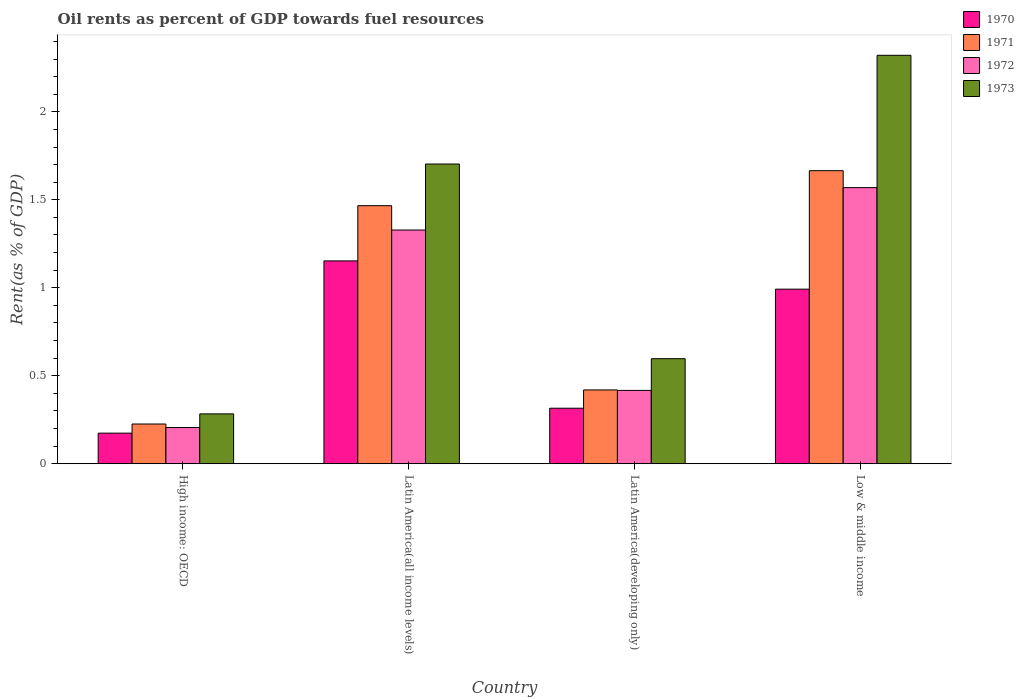Are the number of bars per tick equal to the number of legend labels?
Your answer should be very brief. Yes. Are the number of bars on each tick of the X-axis equal?
Give a very brief answer. Yes. How many bars are there on the 4th tick from the left?
Keep it short and to the point. 4. How many bars are there on the 4th tick from the right?
Make the answer very short. 4. What is the label of the 3rd group of bars from the left?
Offer a terse response. Latin America(developing only). In how many cases, is the number of bars for a given country not equal to the number of legend labels?
Your answer should be compact. 0. What is the oil rent in 1972 in Low & middle income?
Provide a short and direct response. 1.57. Across all countries, what is the maximum oil rent in 1970?
Your answer should be compact. 1.15. Across all countries, what is the minimum oil rent in 1973?
Offer a terse response. 0.28. In which country was the oil rent in 1971 minimum?
Provide a succinct answer. High income: OECD. What is the total oil rent in 1972 in the graph?
Keep it short and to the point. 3.52. What is the difference between the oil rent in 1972 in High income: OECD and that in Latin America(all income levels)?
Your answer should be very brief. -1.12. What is the difference between the oil rent in 1971 in Low & middle income and the oil rent in 1972 in Latin America(all income levels)?
Your response must be concise. 0.34. What is the average oil rent in 1973 per country?
Give a very brief answer. 1.23. What is the difference between the oil rent of/in 1971 and oil rent of/in 1970 in Low & middle income?
Your response must be concise. 0.67. What is the ratio of the oil rent in 1972 in Latin America(developing only) to that in Low & middle income?
Keep it short and to the point. 0.27. Is the difference between the oil rent in 1971 in Latin America(all income levels) and Latin America(developing only) greater than the difference between the oil rent in 1970 in Latin America(all income levels) and Latin America(developing only)?
Your answer should be very brief. Yes. What is the difference between the highest and the second highest oil rent in 1970?
Ensure brevity in your answer.  -0.16. What is the difference between the highest and the lowest oil rent in 1970?
Your answer should be very brief. 0.98. In how many countries, is the oil rent in 1971 greater than the average oil rent in 1971 taken over all countries?
Your answer should be very brief. 2. Is it the case that in every country, the sum of the oil rent in 1970 and oil rent in 1971 is greater than the sum of oil rent in 1973 and oil rent in 1972?
Keep it short and to the point. No. What does the 4th bar from the right in Latin America(all income levels) represents?
Make the answer very short. 1970. What is the difference between two consecutive major ticks on the Y-axis?
Offer a terse response. 0.5. Are the values on the major ticks of Y-axis written in scientific E-notation?
Ensure brevity in your answer.  No. Does the graph contain any zero values?
Provide a short and direct response. No. Does the graph contain grids?
Your answer should be compact. No. How are the legend labels stacked?
Make the answer very short. Vertical. What is the title of the graph?
Give a very brief answer. Oil rents as percent of GDP towards fuel resources. What is the label or title of the Y-axis?
Your response must be concise. Rent(as % of GDP). What is the Rent(as % of GDP) of 1970 in High income: OECD?
Ensure brevity in your answer.  0.17. What is the Rent(as % of GDP) in 1971 in High income: OECD?
Your answer should be very brief. 0.23. What is the Rent(as % of GDP) of 1972 in High income: OECD?
Your answer should be compact. 0.21. What is the Rent(as % of GDP) in 1973 in High income: OECD?
Your answer should be very brief. 0.28. What is the Rent(as % of GDP) in 1970 in Latin America(all income levels)?
Provide a short and direct response. 1.15. What is the Rent(as % of GDP) in 1971 in Latin America(all income levels)?
Keep it short and to the point. 1.47. What is the Rent(as % of GDP) of 1972 in Latin America(all income levels)?
Your answer should be very brief. 1.33. What is the Rent(as % of GDP) of 1973 in Latin America(all income levels)?
Offer a terse response. 1.7. What is the Rent(as % of GDP) of 1970 in Latin America(developing only)?
Your answer should be compact. 0.32. What is the Rent(as % of GDP) of 1971 in Latin America(developing only)?
Provide a succinct answer. 0.42. What is the Rent(as % of GDP) of 1972 in Latin America(developing only)?
Your answer should be compact. 0.42. What is the Rent(as % of GDP) in 1973 in Latin America(developing only)?
Keep it short and to the point. 0.6. What is the Rent(as % of GDP) of 1970 in Low & middle income?
Your answer should be compact. 0.99. What is the Rent(as % of GDP) of 1971 in Low & middle income?
Offer a very short reply. 1.67. What is the Rent(as % of GDP) in 1972 in Low & middle income?
Offer a terse response. 1.57. What is the Rent(as % of GDP) of 1973 in Low & middle income?
Keep it short and to the point. 2.32. Across all countries, what is the maximum Rent(as % of GDP) of 1970?
Your answer should be compact. 1.15. Across all countries, what is the maximum Rent(as % of GDP) in 1971?
Your answer should be very brief. 1.67. Across all countries, what is the maximum Rent(as % of GDP) in 1972?
Your answer should be compact. 1.57. Across all countries, what is the maximum Rent(as % of GDP) of 1973?
Ensure brevity in your answer.  2.32. Across all countries, what is the minimum Rent(as % of GDP) of 1970?
Offer a terse response. 0.17. Across all countries, what is the minimum Rent(as % of GDP) of 1971?
Provide a short and direct response. 0.23. Across all countries, what is the minimum Rent(as % of GDP) of 1972?
Offer a very short reply. 0.21. Across all countries, what is the minimum Rent(as % of GDP) in 1973?
Give a very brief answer. 0.28. What is the total Rent(as % of GDP) in 1970 in the graph?
Make the answer very short. 2.63. What is the total Rent(as % of GDP) of 1971 in the graph?
Give a very brief answer. 3.78. What is the total Rent(as % of GDP) of 1972 in the graph?
Make the answer very short. 3.52. What is the total Rent(as % of GDP) in 1973 in the graph?
Give a very brief answer. 4.9. What is the difference between the Rent(as % of GDP) in 1970 in High income: OECD and that in Latin America(all income levels)?
Offer a terse response. -0.98. What is the difference between the Rent(as % of GDP) in 1971 in High income: OECD and that in Latin America(all income levels)?
Your answer should be very brief. -1.24. What is the difference between the Rent(as % of GDP) of 1972 in High income: OECD and that in Latin America(all income levels)?
Provide a succinct answer. -1.12. What is the difference between the Rent(as % of GDP) in 1973 in High income: OECD and that in Latin America(all income levels)?
Give a very brief answer. -1.42. What is the difference between the Rent(as % of GDP) of 1970 in High income: OECD and that in Latin America(developing only)?
Offer a very short reply. -0.14. What is the difference between the Rent(as % of GDP) of 1971 in High income: OECD and that in Latin America(developing only)?
Make the answer very short. -0.19. What is the difference between the Rent(as % of GDP) of 1972 in High income: OECD and that in Latin America(developing only)?
Your response must be concise. -0.21. What is the difference between the Rent(as % of GDP) of 1973 in High income: OECD and that in Latin America(developing only)?
Your answer should be very brief. -0.31. What is the difference between the Rent(as % of GDP) of 1970 in High income: OECD and that in Low & middle income?
Provide a short and direct response. -0.82. What is the difference between the Rent(as % of GDP) of 1971 in High income: OECD and that in Low & middle income?
Offer a very short reply. -1.44. What is the difference between the Rent(as % of GDP) of 1972 in High income: OECD and that in Low & middle income?
Give a very brief answer. -1.36. What is the difference between the Rent(as % of GDP) in 1973 in High income: OECD and that in Low & middle income?
Your response must be concise. -2.04. What is the difference between the Rent(as % of GDP) in 1970 in Latin America(all income levels) and that in Latin America(developing only)?
Your answer should be very brief. 0.84. What is the difference between the Rent(as % of GDP) in 1971 in Latin America(all income levels) and that in Latin America(developing only)?
Your answer should be very brief. 1.05. What is the difference between the Rent(as % of GDP) of 1972 in Latin America(all income levels) and that in Latin America(developing only)?
Your answer should be very brief. 0.91. What is the difference between the Rent(as % of GDP) of 1973 in Latin America(all income levels) and that in Latin America(developing only)?
Your answer should be very brief. 1.11. What is the difference between the Rent(as % of GDP) of 1970 in Latin America(all income levels) and that in Low & middle income?
Make the answer very short. 0.16. What is the difference between the Rent(as % of GDP) of 1971 in Latin America(all income levels) and that in Low & middle income?
Ensure brevity in your answer.  -0.2. What is the difference between the Rent(as % of GDP) in 1972 in Latin America(all income levels) and that in Low & middle income?
Ensure brevity in your answer.  -0.24. What is the difference between the Rent(as % of GDP) in 1973 in Latin America(all income levels) and that in Low & middle income?
Ensure brevity in your answer.  -0.62. What is the difference between the Rent(as % of GDP) of 1970 in Latin America(developing only) and that in Low & middle income?
Keep it short and to the point. -0.68. What is the difference between the Rent(as % of GDP) of 1971 in Latin America(developing only) and that in Low & middle income?
Provide a short and direct response. -1.25. What is the difference between the Rent(as % of GDP) in 1972 in Latin America(developing only) and that in Low & middle income?
Keep it short and to the point. -1.15. What is the difference between the Rent(as % of GDP) of 1973 in Latin America(developing only) and that in Low & middle income?
Offer a very short reply. -1.72. What is the difference between the Rent(as % of GDP) in 1970 in High income: OECD and the Rent(as % of GDP) in 1971 in Latin America(all income levels)?
Make the answer very short. -1.29. What is the difference between the Rent(as % of GDP) in 1970 in High income: OECD and the Rent(as % of GDP) in 1972 in Latin America(all income levels)?
Provide a short and direct response. -1.15. What is the difference between the Rent(as % of GDP) in 1970 in High income: OECD and the Rent(as % of GDP) in 1973 in Latin America(all income levels)?
Offer a terse response. -1.53. What is the difference between the Rent(as % of GDP) of 1971 in High income: OECD and the Rent(as % of GDP) of 1972 in Latin America(all income levels)?
Your answer should be very brief. -1.1. What is the difference between the Rent(as % of GDP) of 1971 in High income: OECD and the Rent(as % of GDP) of 1973 in Latin America(all income levels)?
Your response must be concise. -1.48. What is the difference between the Rent(as % of GDP) in 1972 in High income: OECD and the Rent(as % of GDP) in 1973 in Latin America(all income levels)?
Give a very brief answer. -1.5. What is the difference between the Rent(as % of GDP) of 1970 in High income: OECD and the Rent(as % of GDP) of 1971 in Latin America(developing only)?
Provide a succinct answer. -0.25. What is the difference between the Rent(as % of GDP) of 1970 in High income: OECD and the Rent(as % of GDP) of 1972 in Latin America(developing only)?
Provide a short and direct response. -0.24. What is the difference between the Rent(as % of GDP) in 1970 in High income: OECD and the Rent(as % of GDP) in 1973 in Latin America(developing only)?
Your response must be concise. -0.42. What is the difference between the Rent(as % of GDP) in 1971 in High income: OECD and the Rent(as % of GDP) in 1972 in Latin America(developing only)?
Provide a short and direct response. -0.19. What is the difference between the Rent(as % of GDP) of 1971 in High income: OECD and the Rent(as % of GDP) of 1973 in Latin America(developing only)?
Offer a terse response. -0.37. What is the difference between the Rent(as % of GDP) in 1972 in High income: OECD and the Rent(as % of GDP) in 1973 in Latin America(developing only)?
Your response must be concise. -0.39. What is the difference between the Rent(as % of GDP) in 1970 in High income: OECD and the Rent(as % of GDP) in 1971 in Low & middle income?
Provide a short and direct response. -1.49. What is the difference between the Rent(as % of GDP) in 1970 in High income: OECD and the Rent(as % of GDP) in 1972 in Low & middle income?
Offer a terse response. -1.4. What is the difference between the Rent(as % of GDP) of 1970 in High income: OECD and the Rent(as % of GDP) of 1973 in Low & middle income?
Your answer should be compact. -2.15. What is the difference between the Rent(as % of GDP) of 1971 in High income: OECD and the Rent(as % of GDP) of 1972 in Low & middle income?
Offer a terse response. -1.34. What is the difference between the Rent(as % of GDP) of 1971 in High income: OECD and the Rent(as % of GDP) of 1973 in Low & middle income?
Ensure brevity in your answer.  -2.1. What is the difference between the Rent(as % of GDP) in 1972 in High income: OECD and the Rent(as % of GDP) in 1973 in Low & middle income?
Keep it short and to the point. -2.12. What is the difference between the Rent(as % of GDP) in 1970 in Latin America(all income levels) and the Rent(as % of GDP) in 1971 in Latin America(developing only)?
Your answer should be very brief. 0.73. What is the difference between the Rent(as % of GDP) in 1970 in Latin America(all income levels) and the Rent(as % of GDP) in 1972 in Latin America(developing only)?
Provide a short and direct response. 0.74. What is the difference between the Rent(as % of GDP) in 1970 in Latin America(all income levels) and the Rent(as % of GDP) in 1973 in Latin America(developing only)?
Provide a short and direct response. 0.56. What is the difference between the Rent(as % of GDP) of 1971 in Latin America(all income levels) and the Rent(as % of GDP) of 1972 in Latin America(developing only)?
Give a very brief answer. 1.05. What is the difference between the Rent(as % of GDP) of 1971 in Latin America(all income levels) and the Rent(as % of GDP) of 1973 in Latin America(developing only)?
Ensure brevity in your answer.  0.87. What is the difference between the Rent(as % of GDP) of 1972 in Latin America(all income levels) and the Rent(as % of GDP) of 1973 in Latin America(developing only)?
Provide a short and direct response. 0.73. What is the difference between the Rent(as % of GDP) of 1970 in Latin America(all income levels) and the Rent(as % of GDP) of 1971 in Low & middle income?
Make the answer very short. -0.51. What is the difference between the Rent(as % of GDP) in 1970 in Latin America(all income levels) and the Rent(as % of GDP) in 1972 in Low & middle income?
Provide a succinct answer. -0.42. What is the difference between the Rent(as % of GDP) of 1970 in Latin America(all income levels) and the Rent(as % of GDP) of 1973 in Low & middle income?
Provide a short and direct response. -1.17. What is the difference between the Rent(as % of GDP) of 1971 in Latin America(all income levels) and the Rent(as % of GDP) of 1972 in Low & middle income?
Offer a terse response. -0.1. What is the difference between the Rent(as % of GDP) of 1971 in Latin America(all income levels) and the Rent(as % of GDP) of 1973 in Low & middle income?
Give a very brief answer. -0.85. What is the difference between the Rent(as % of GDP) of 1972 in Latin America(all income levels) and the Rent(as % of GDP) of 1973 in Low & middle income?
Provide a succinct answer. -0.99. What is the difference between the Rent(as % of GDP) of 1970 in Latin America(developing only) and the Rent(as % of GDP) of 1971 in Low & middle income?
Offer a terse response. -1.35. What is the difference between the Rent(as % of GDP) of 1970 in Latin America(developing only) and the Rent(as % of GDP) of 1972 in Low & middle income?
Provide a succinct answer. -1.25. What is the difference between the Rent(as % of GDP) in 1970 in Latin America(developing only) and the Rent(as % of GDP) in 1973 in Low & middle income?
Offer a very short reply. -2.01. What is the difference between the Rent(as % of GDP) of 1971 in Latin America(developing only) and the Rent(as % of GDP) of 1972 in Low & middle income?
Give a very brief answer. -1.15. What is the difference between the Rent(as % of GDP) of 1971 in Latin America(developing only) and the Rent(as % of GDP) of 1973 in Low & middle income?
Make the answer very short. -1.9. What is the difference between the Rent(as % of GDP) in 1972 in Latin America(developing only) and the Rent(as % of GDP) in 1973 in Low & middle income?
Ensure brevity in your answer.  -1.9. What is the average Rent(as % of GDP) of 1970 per country?
Provide a succinct answer. 0.66. What is the average Rent(as % of GDP) in 1971 per country?
Give a very brief answer. 0.94. What is the average Rent(as % of GDP) in 1973 per country?
Ensure brevity in your answer.  1.23. What is the difference between the Rent(as % of GDP) in 1970 and Rent(as % of GDP) in 1971 in High income: OECD?
Offer a terse response. -0.05. What is the difference between the Rent(as % of GDP) of 1970 and Rent(as % of GDP) of 1972 in High income: OECD?
Your response must be concise. -0.03. What is the difference between the Rent(as % of GDP) of 1970 and Rent(as % of GDP) of 1973 in High income: OECD?
Keep it short and to the point. -0.11. What is the difference between the Rent(as % of GDP) in 1971 and Rent(as % of GDP) in 1972 in High income: OECD?
Your response must be concise. 0.02. What is the difference between the Rent(as % of GDP) in 1971 and Rent(as % of GDP) in 1973 in High income: OECD?
Provide a short and direct response. -0.06. What is the difference between the Rent(as % of GDP) in 1972 and Rent(as % of GDP) in 1973 in High income: OECD?
Your response must be concise. -0.08. What is the difference between the Rent(as % of GDP) in 1970 and Rent(as % of GDP) in 1971 in Latin America(all income levels)?
Ensure brevity in your answer.  -0.31. What is the difference between the Rent(as % of GDP) in 1970 and Rent(as % of GDP) in 1972 in Latin America(all income levels)?
Make the answer very short. -0.18. What is the difference between the Rent(as % of GDP) in 1970 and Rent(as % of GDP) in 1973 in Latin America(all income levels)?
Your answer should be very brief. -0.55. What is the difference between the Rent(as % of GDP) of 1971 and Rent(as % of GDP) of 1972 in Latin America(all income levels)?
Offer a very short reply. 0.14. What is the difference between the Rent(as % of GDP) of 1971 and Rent(as % of GDP) of 1973 in Latin America(all income levels)?
Ensure brevity in your answer.  -0.24. What is the difference between the Rent(as % of GDP) of 1972 and Rent(as % of GDP) of 1973 in Latin America(all income levels)?
Ensure brevity in your answer.  -0.38. What is the difference between the Rent(as % of GDP) of 1970 and Rent(as % of GDP) of 1971 in Latin America(developing only)?
Provide a succinct answer. -0.1. What is the difference between the Rent(as % of GDP) in 1970 and Rent(as % of GDP) in 1972 in Latin America(developing only)?
Give a very brief answer. -0.1. What is the difference between the Rent(as % of GDP) of 1970 and Rent(as % of GDP) of 1973 in Latin America(developing only)?
Your answer should be compact. -0.28. What is the difference between the Rent(as % of GDP) of 1971 and Rent(as % of GDP) of 1972 in Latin America(developing only)?
Provide a succinct answer. 0. What is the difference between the Rent(as % of GDP) of 1971 and Rent(as % of GDP) of 1973 in Latin America(developing only)?
Your answer should be compact. -0.18. What is the difference between the Rent(as % of GDP) of 1972 and Rent(as % of GDP) of 1973 in Latin America(developing only)?
Give a very brief answer. -0.18. What is the difference between the Rent(as % of GDP) of 1970 and Rent(as % of GDP) of 1971 in Low & middle income?
Your answer should be compact. -0.67. What is the difference between the Rent(as % of GDP) of 1970 and Rent(as % of GDP) of 1972 in Low & middle income?
Your answer should be very brief. -0.58. What is the difference between the Rent(as % of GDP) of 1970 and Rent(as % of GDP) of 1973 in Low & middle income?
Keep it short and to the point. -1.33. What is the difference between the Rent(as % of GDP) in 1971 and Rent(as % of GDP) in 1972 in Low & middle income?
Offer a terse response. 0.1. What is the difference between the Rent(as % of GDP) of 1971 and Rent(as % of GDP) of 1973 in Low & middle income?
Keep it short and to the point. -0.66. What is the difference between the Rent(as % of GDP) in 1972 and Rent(as % of GDP) in 1973 in Low & middle income?
Offer a very short reply. -0.75. What is the ratio of the Rent(as % of GDP) of 1970 in High income: OECD to that in Latin America(all income levels)?
Offer a terse response. 0.15. What is the ratio of the Rent(as % of GDP) of 1971 in High income: OECD to that in Latin America(all income levels)?
Your answer should be very brief. 0.15. What is the ratio of the Rent(as % of GDP) in 1972 in High income: OECD to that in Latin America(all income levels)?
Offer a terse response. 0.15. What is the ratio of the Rent(as % of GDP) in 1973 in High income: OECD to that in Latin America(all income levels)?
Give a very brief answer. 0.17. What is the ratio of the Rent(as % of GDP) of 1970 in High income: OECD to that in Latin America(developing only)?
Your answer should be compact. 0.55. What is the ratio of the Rent(as % of GDP) of 1971 in High income: OECD to that in Latin America(developing only)?
Make the answer very short. 0.54. What is the ratio of the Rent(as % of GDP) of 1972 in High income: OECD to that in Latin America(developing only)?
Offer a terse response. 0.49. What is the ratio of the Rent(as % of GDP) of 1973 in High income: OECD to that in Latin America(developing only)?
Your answer should be very brief. 0.47. What is the ratio of the Rent(as % of GDP) in 1970 in High income: OECD to that in Low & middle income?
Your answer should be very brief. 0.18. What is the ratio of the Rent(as % of GDP) in 1971 in High income: OECD to that in Low & middle income?
Keep it short and to the point. 0.14. What is the ratio of the Rent(as % of GDP) in 1972 in High income: OECD to that in Low & middle income?
Provide a succinct answer. 0.13. What is the ratio of the Rent(as % of GDP) of 1973 in High income: OECD to that in Low & middle income?
Provide a succinct answer. 0.12. What is the ratio of the Rent(as % of GDP) in 1970 in Latin America(all income levels) to that in Latin America(developing only)?
Keep it short and to the point. 3.65. What is the ratio of the Rent(as % of GDP) of 1971 in Latin America(all income levels) to that in Latin America(developing only)?
Your answer should be very brief. 3.5. What is the ratio of the Rent(as % of GDP) in 1972 in Latin America(all income levels) to that in Latin America(developing only)?
Offer a very short reply. 3.19. What is the ratio of the Rent(as % of GDP) of 1973 in Latin America(all income levels) to that in Latin America(developing only)?
Provide a short and direct response. 2.85. What is the ratio of the Rent(as % of GDP) of 1970 in Latin America(all income levels) to that in Low & middle income?
Your response must be concise. 1.16. What is the ratio of the Rent(as % of GDP) of 1971 in Latin America(all income levels) to that in Low & middle income?
Give a very brief answer. 0.88. What is the ratio of the Rent(as % of GDP) of 1972 in Latin America(all income levels) to that in Low & middle income?
Your response must be concise. 0.85. What is the ratio of the Rent(as % of GDP) of 1973 in Latin America(all income levels) to that in Low & middle income?
Your response must be concise. 0.73. What is the ratio of the Rent(as % of GDP) of 1970 in Latin America(developing only) to that in Low & middle income?
Keep it short and to the point. 0.32. What is the ratio of the Rent(as % of GDP) in 1971 in Latin America(developing only) to that in Low & middle income?
Your answer should be compact. 0.25. What is the ratio of the Rent(as % of GDP) in 1972 in Latin America(developing only) to that in Low & middle income?
Your answer should be compact. 0.27. What is the ratio of the Rent(as % of GDP) in 1973 in Latin America(developing only) to that in Low & middle income?
Your answer should be very brief. 0.26. What is the difference between the highest and the second highest Rent(as % of GDP) in 1970?
Your answer should be very brief. 0.16. What is the difference between the highest and the second highest Rent(as % of GDP) in 1971?
Keep it short and to the point. 0.2. What is the difference between the highest and the second highest Rent(as % of GDP) of 1972?
Your response must be concise. 0.24. What is the difference between the highest and the second highest Rent(as % of GDP) of 1973?
Provide a succinct answer. 0.62. What is the difference between the highest and the lowest Rent(as % of GDP) in 1970?
Keep it short and to the point. 0.98. What is the difference between the highest and the lowest Rent(as % of GDP) in 1971?
Keep it short and to the point. 1.44. What is the difference between the highest and the lowest Rent(as % of GDP) in 1972?
Your answer should be very brief. 1.36. What is the difference between the highest and the lowest Rent(as % of GDP) in 1973?
Ensure brevity in your answer.  2.04. 